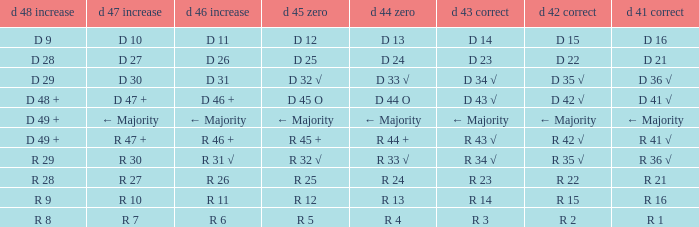What is the value of D 45 O when the value of D 44 O is ← majority? ← Majority. 